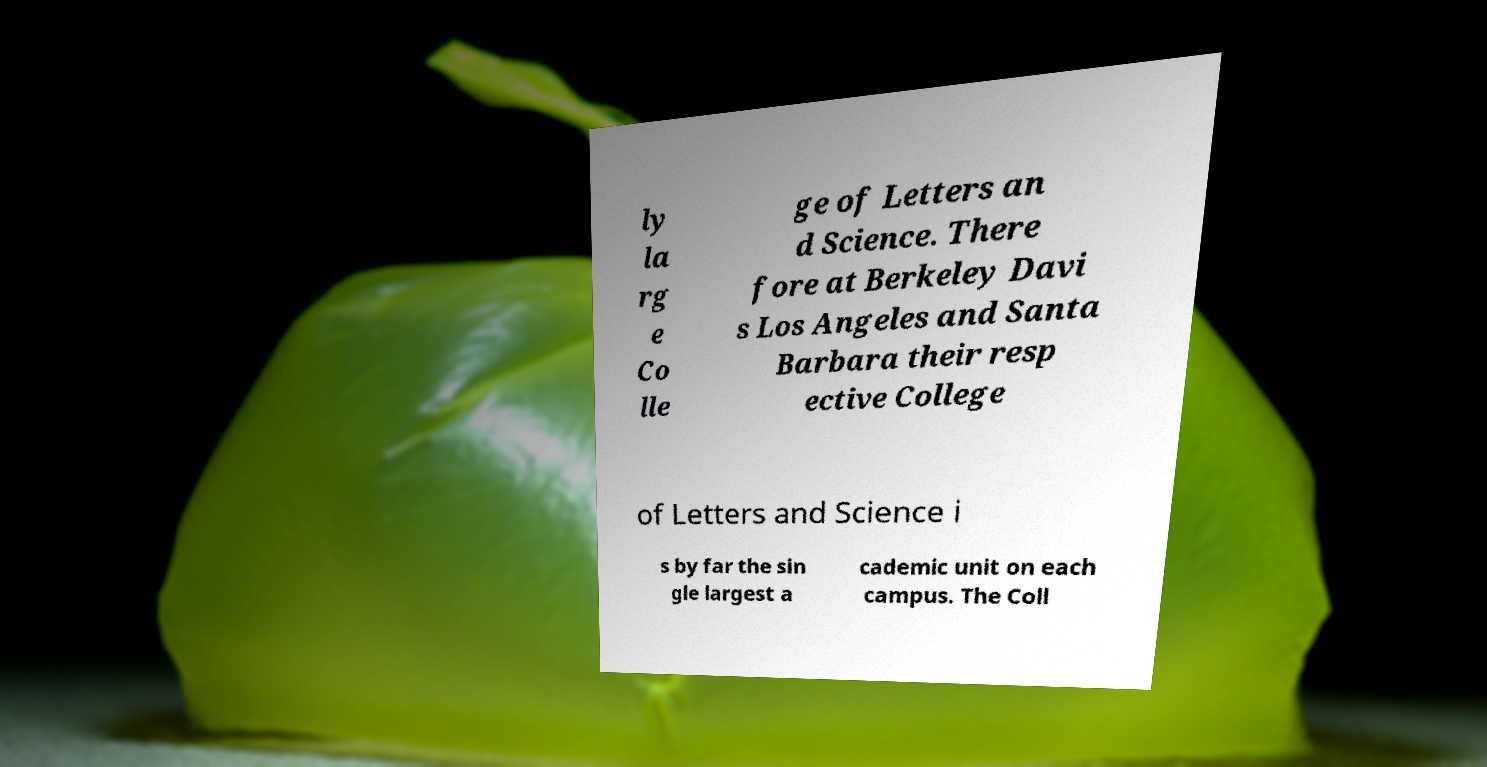What messages or text are displayed in this image? I need them in a readable, typed format. ly la rg e Co lle ge of Letters an d Science. There fore at Berkeley Davi s Los Angeles and Santa Barbara their resp ective College of Letters and Science i s by far the sin gle largest a cademic unit on each campus. The Coll 